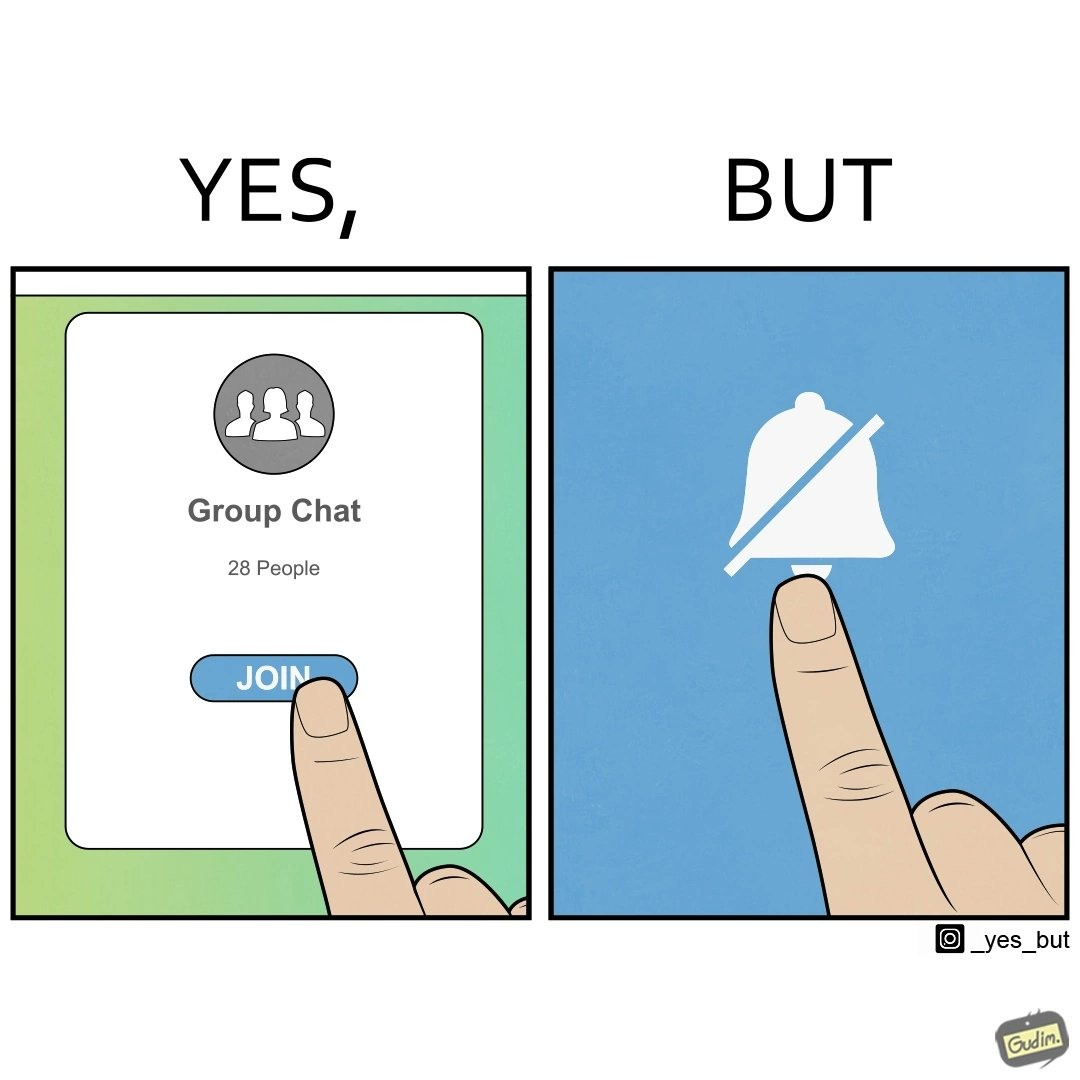Does this image contain satire or humor? Yes, this image is satirical. 